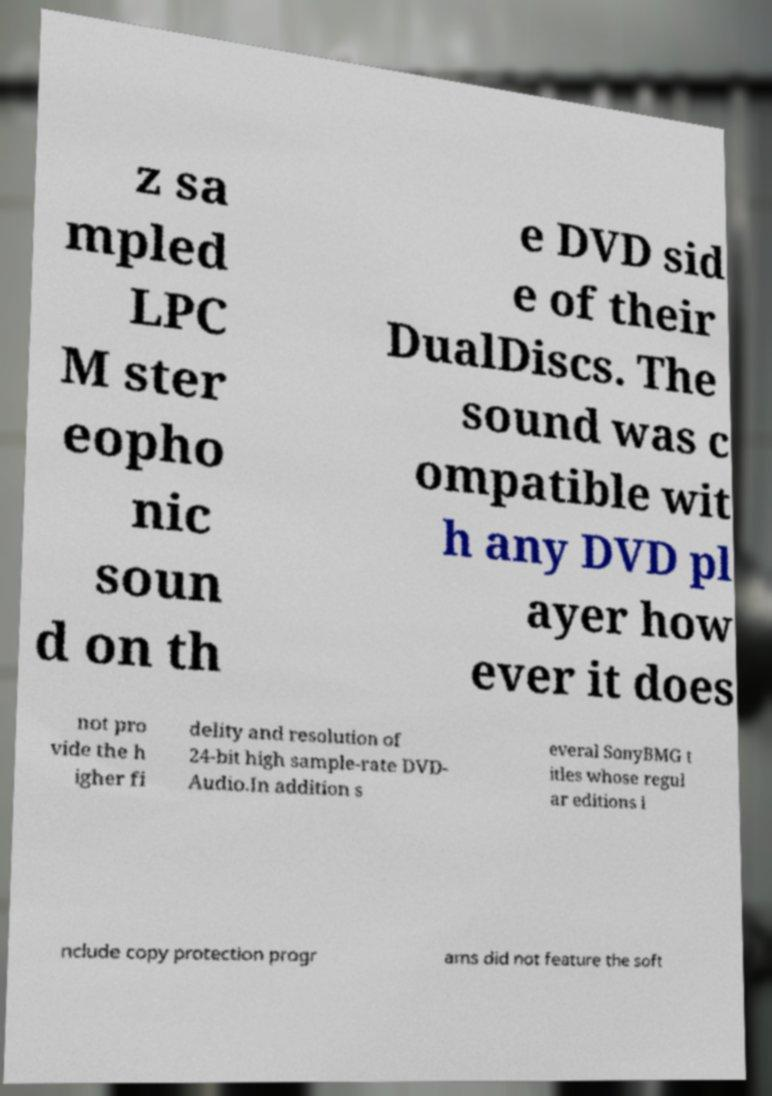What messages or text are displayed in this image? I need them in a readable, typed format. z sa mpled LPC M ster eopho nic soun d on th e DVD sid e of their DualDiscs. The sound was c ompatible wit h any DVD pl ayer how ever it does not pro vide the h igher fi delity and resolution of 24-bit high sample-rate DVD- Audio.In addition s everal SonyBMG t itles whose regul ar editions i nclude copy protection progr ams did not feature the soft 